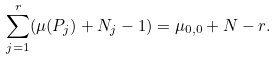Convert formula to latex. <formula><loc_0><loc_0><loc_500><loc_500>\sum _ { j = 1 } ^ { r } ( \mu ( P _ { j } ) + N _ { j } - 1 ) = \mu _ { 0 , 0 } + N - r .</formula> 